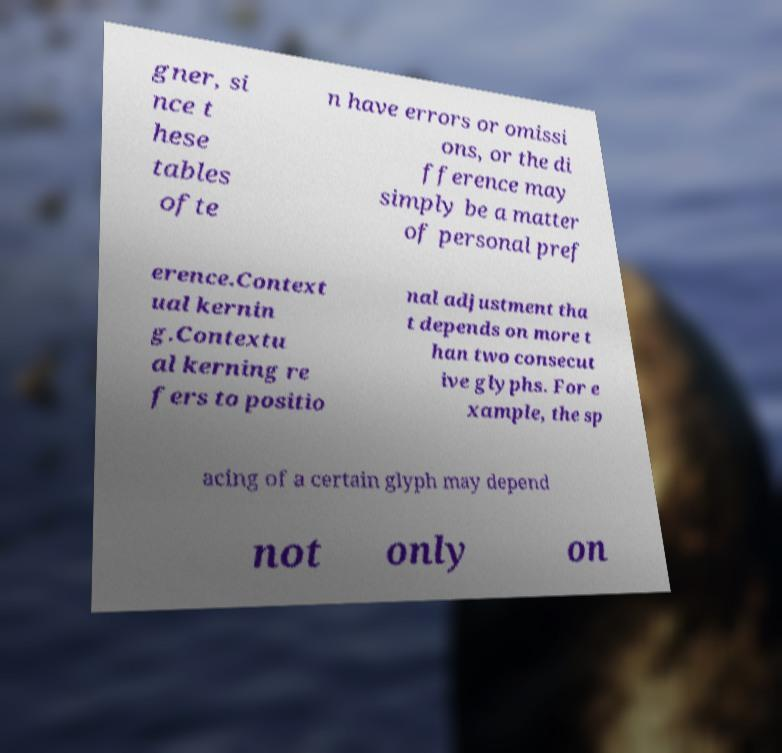Could you assist in decoding the text presented in this image and type it out clearly? gner, si nce t hese tables ofte n have errors or omissi ons, or the di fference may simply be a matter of personal pref erence.Context ual kernin g.Contextu al kerning re fers to positio nal adjustment tha t depends on more t han two consecut ive glyphs. For e xample, the sp acing of a certain glyph may depend not only on 